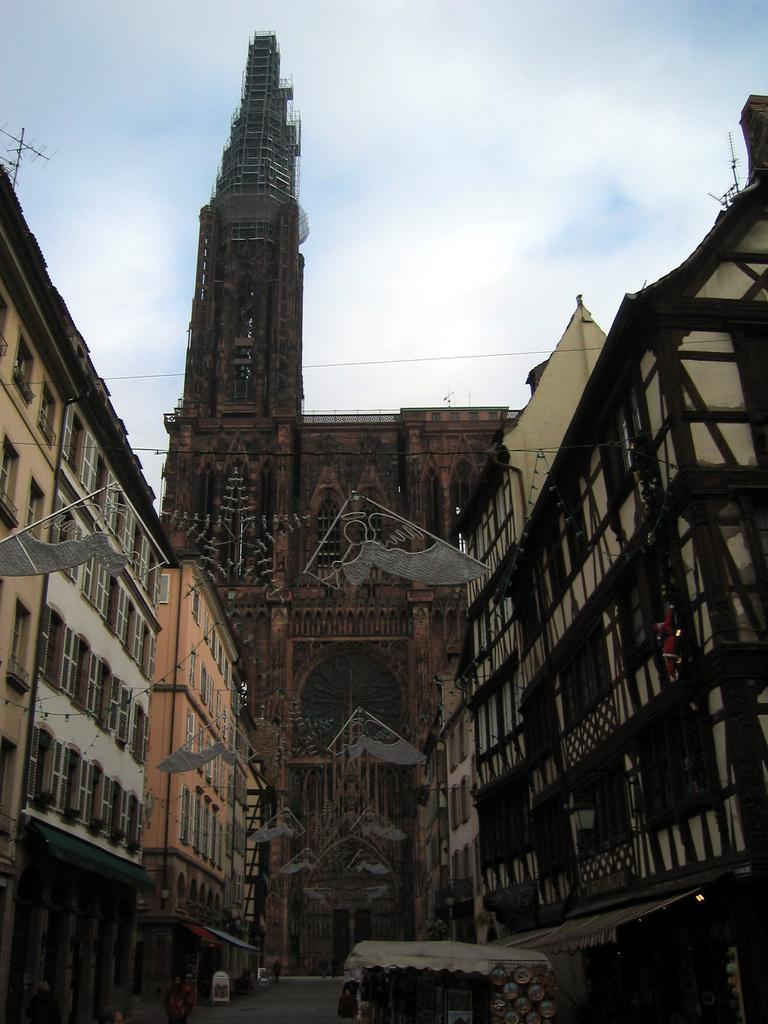What type of structures can be seen in the image? There are buildings in the image. What material is used for the rods visible in the image? Metal rods are visible in the image. What is present in the sky in the image? Clouds are present in the image. How many bikes are parked next to the buildings in the image? There are no bikes present in the image; only buildings, metal rods, and clouds can be seen. What type of liquid can be seen flowing from the rods in the image? There is no liquid flowing from the rods in the image; only metal rods are visible. 